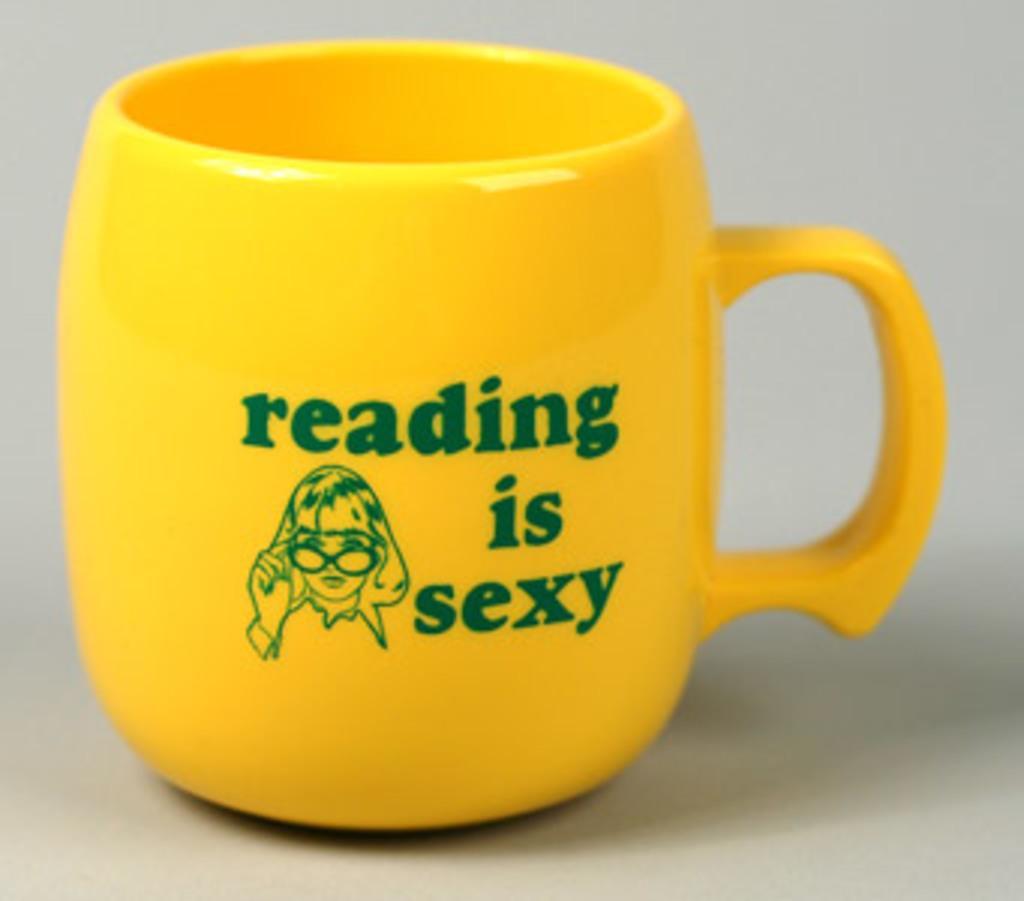Please provide a concise description of this image. There is a cup in the picture on which is written, reading is sexy. 